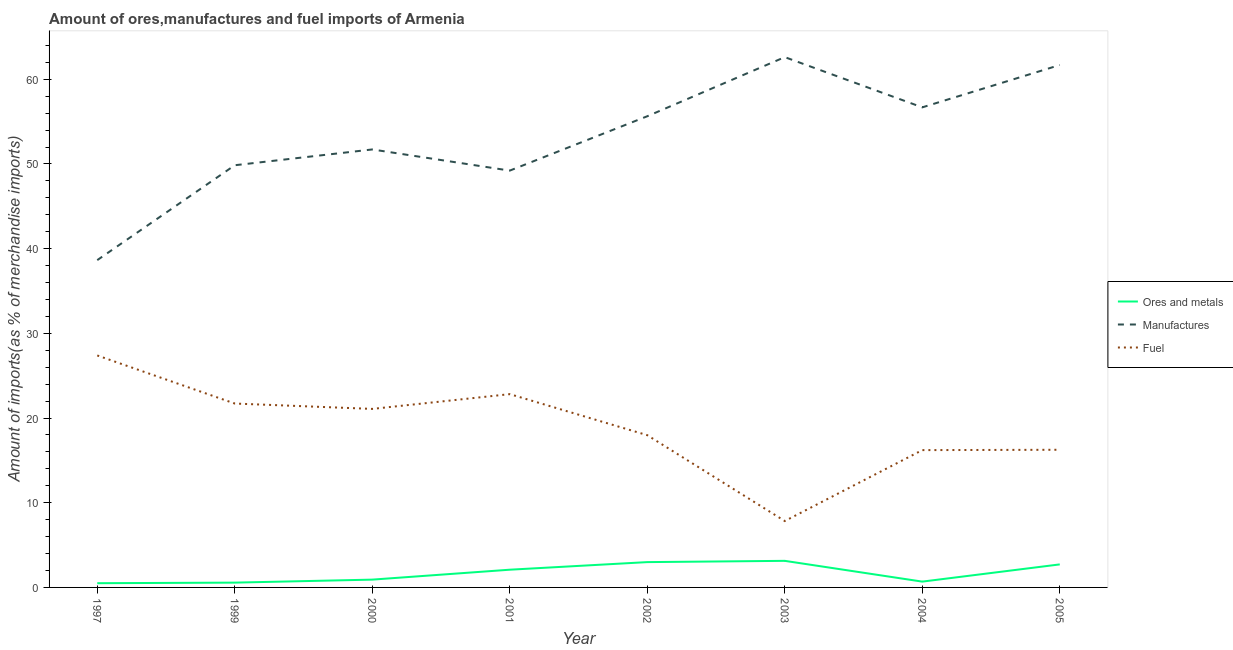How many different coloured lines are there?
Keep it short and to the point. 3. Does the line corresponding to percentage of ores and metals imports intersect with the line corresponding to percentage of manufactures imports?
Make the answer very short. No. What is the percentage of fuel imports in 2001?
Give a very brief answer. 22.82. Across all years, what is the maximum percentage of fuel imports?
Your answer should be very brief. 27.39. Across all years, what is the minimum percentage of manufactures imports?
Ensure brevity in your answer.  38.64. What is the total percentage of ores and metals imports in the graph?
Provide a short and direct response. 13.61. What is the difference between the percentage of ores and metals imports in 2004 and that in 2005?
Offer a terse response. -2.03. What is the difference between the percentage of manufactures imports in 1999 and the percentage of fuel imports in 2005?
Offer a terse response. 33.59. What is the average percentage of fuel imports per year?
Your response must be concise. 18.91. In the year 1999, what is the difference between the percentage of ores and metals imports and percentage of manufactures imports?
Your answer should be compact. -49.28. In how many years, is the percentage of fuel imports greater than 42 %?
Ensure brevity in your answer.  0. What is the ratio of the percentage of fuel imports in 2002 to that in 2004?
Your answer should be very brief. 1.11. What is the difference between the highest and the second highest percentage of fuel imports?
Provide a succinct answer. 4.57. What is the difference between the highest and the lowest percentage of manufactures imports?
Provide a short and direct response. 23.97. In how many years, is the percentage of manufactures imports greater than the average percentage of manufactures imports taken over all years?
Ensure brevity in your answer.  4. Is the sum of the percentage of manufactures imports in 2001 and 2005 greater than the maximum percentage of fuel imports across all years?
Your answer should be compact. Yes. Is the percentage of ores and metals imports strictly greater than the percentage of manufactures imports over the years?
Offer a very short reply. No. What is the difference between two consecutive major ticks on the Y-axis?
Provide a short and direct response. 10. What is the title of the graph?
Your answer should be very brief. Amount of ores,manufactures and fuel imports of Armenia. Does "Transport equipments" appear as one of the legend labels in the graph?
Your answer should be compact. No. What is the label or title of the X-axis?
Your answer should be very brief. Year. What is the label or title of the Y-axis?
Your response must be concise. Amount of imports(as % of merchandise imports). What is the Amount of imports(as % of merchandise imports) of Ores and metals in 1997?
Offer a terse response. 0.5. What is the Amount of imports(as % of merchandise imports) in Manufactures in 1997?
Offer a very short reply. 38.64. What is the Amount of imports(as % of merchandise imports) in Fuel in 1997?
Your answer should be compact. 27.39. What is the Amount of imports(as % of merchandise imports) of Ores and metals in 1999?
Make the answer very short. 0.57. What is the Amount of imports(as % of merchandise imports) of Manufactures in 1999?
Offer a terse response. 49.85. What is the Amount of imports(as % of merchandise imports) in Fuel in 1999?
Your answer should be compact. 21.71. What is the Amount of imports(as % of merchandise imports) in Ores and metals in 2000?
Ensure brevity in your answer.  0.92. What is the Amount of imports(as % of merchandise imports) in Manufactures in 2000?
Provide a short and direct response. 51.71. What is the Amount of imports(as % of merchandise imports) in Fuel in 2000?
Keep it short and to the point. 21.08. What is the Amount of imports(as % of merchandise imports) in Ores and metals in 2001?
Keep it short and to the point. 2.09. What is the Amount of imports(as % of merchandise imports) in Manufactures in 2001?
Give a very brief answer. 49.21. What is the Amount of imports(as % of merchandise imports) in Fuel in 2001?
Make the answer very short. 22.82. What is the Amount of imports(as % of merchandise imports) in Ores and metals in 2002?
Your answer should be very brief. 2.99. What is the Amount of imports(as % of merchandise imports) of Manufactures in 2002?
Provide a succinct answer. 55.63. What is the Amount of imports(as % of merchandise imports) in Fuel in 2002?
Give a very brief answer. 17.98. What is the Amount of imports(as % of merchandise imports) in Ores and metals in 2003?
Provide a succinct answer. 3.14. What is the Amount of imports(as % of merchandise imports) in Manufactures in 2003?
Your response must be concise. 62.61. What is the Amount of imports(as % of merchandise imports) of Fuel in 2003?
Ensure brevity in your answer.  7.84. What is the Amount of imports(as % of merchandise imports) of Ores and metals in 2004?
Offer a terse response. 0.69. What is the Amount of imports(as % of merchandise imports) in Manufactures in 2004?
Your answer should be compact. 56.68. What is the Amount of imports(as % of merchandise imports) of Fuel in 2004?
Make the answer very short. 16.21. What is the Amount of imports(as % of merchandise imports) of Ores and metals in 2005?
Provide a succinct answer. 2.72. What is the Amount of imports(as % of merchandise imports) in Manufactures in 2005?
Make the answer very short. 61.68. What is the Amount of imports(as % of merchandise imports) of Fuel in 2005?
Your answer should be very brief. 16.25. Across all years, what is the maximum Amount of imports(as % of merchandise imports) in Ores and metals?
Make the answer very short. 3.14. Across all years, what is the maximum Amount of imports(as % of merchandise imports) in Manufactures?
Provide a short and direct response. 62.61. Across all years, what is the maximum Amount of imports(as % of merchandise imports) of Fuel?
Offer a very short reply. 27.39. Across all years, what is the minimum Amount of imports(as % of merchandise imports) in Ores and metals?
Provide a succinct answer. 0.5. Across all years, what is the minimum Amount of imports(as % of merchandise imports) in Manufactures?
Provide a succinct answer. 38.64. Across all years, what is the minimum Amount of imports(as % of merchandise imports) of Fuel?
Your answer should be very brief. 7.84. What is the total Amount of imports(as % of merchandise imports) in Ores and metals in the graph?
Offer a terse response. 13.61. What is the total Amount of imports(as % of merchandise imports) of Manufactures in the graph?
Provide a succinct answer. 426.03. What is the total Amount of imports(as % of merchandise imports) in Fuel in the graph?
Your answer should be compact. 151.28. What is the difference between the Amount of imports(as % of merchandise imports) of Ores and metals in 1997 and that in 1999?
Provide a short and direct response. -0.07. What is the difference between the Amount of imports(as % of merchandise imports) in Manufactures in 1997 and that in 1999?
Provide a succinct answer. -11.2. What is the difference between the Amount of imports(as % of merchandise imports) in Fuel in 1997 and that in 1999?
Give a very brief answer. 5.68. What is the difference between the Amount of imports(as % of merchandise imports) in Ores and metals in 1997 and that in 2000?
Provide a short and direct response. -0.42. What is the difference between the Amount of imports(as % of merchandise imports) of Manufactures in 1997 and that in 2000?
Make the answer very short. -13.07. What is the difference between the Amount of imports(as % of merchandise imports) of Fuel in 1997 and that in 2000?
Provide a short and direct response. 6.31. What is the difference between the Amount of imports(as % of merchandise imports) in Ores and metals in 1997 and that in 2001?
Offer a terse response. -1.59. What is the difference between the Amount of imports(as % of merchandise imports) of Manufactures in 1997 and that in 2001?
Ensure brevity in your answer.  -10.57. What is the difference between the Amount of imports(as % of merchandise imports) in Fuel in 1997 and that in 2001?
Ensure brevity in your answer.  4.57. What is the difference between the Amount of imports(as % of merchandise imports) of Ores and metals in 1997 and that in 2002?
Make the answer very short. -2.49. What is the difference between the Amount of imports(as % of merchandise imports) in Manufactures in 1997 and that in 2002?
Your response must be concise. -16.99. What is the difference between the Amount of imports(as % of merchandise imports) of Fuel in 1997 and that in 2002?
Offer a terse response. 9.41. What is the difference between the Amount of imports(as % of merchandise imports) of Ores and metals in 1997 and that in 2003?
Your answer should be compact. -2.64. What is the difference between the Amount of imports(as % of merchandise imports) in Manufactures in 1997 and that in 2003?
Offer a very short reply. -23.97. What is the difference between the Amount of imports(as % of merchandise imports) in Fuel in 1997 and that in 2003?
Offer a terse response. 19.55. What is the difference between the Amount of imports(as % of merchandise imports) of Ores and metals in 1997 and that in 2004?
Make the answer very short. -0.19. What is the difference between the Amount of imports(as % of merchandise imports) in Manufactures in 1997 and that in 2004?
Keep it short and to the point. -18.04. What is the difference between the Amount of imports(as % of merchandise imports) in Fuel in 1997 and that in 2004?
Give a very brief answer. 11.18. What is the difference between the Amount of imports(as % of merchandise imports) in Ores and metals in 1997 and that in 2005?
Give a very brief answer. -2.22. What is the difference between the Amount of imports(as % of merchandise imports) in Manufactures in 1997 and that in 2005?
Give a very brief answer. -23.04. What is the difference between the Amount of imports(as % of merchandise imports) of Fuel in 1997 and that in 2005?
Offer a very short reply. 11.14. What is the difference between the Amount of imports(as % of merchandise imports) in Ores and metals in 1999 and that in 2000?
Ensure brevity in your answer.  -0.35. What is the difference between the Amount of imports(as % of merchandise imports) of Manufactures in 1999 and that in 2000?
Offer a very short reply. -1.86. What is the difference between the Amount of imports(as % of merchandise imports) of Fuel in 1999 and that in 2000?
Make the answer very short. 0.63. What is the difference between the Amount of imports(as % of merchandise imports) of Ores and metals in 1999 and that in 2001?
Make the answer very short. -1.53. What is the difference between the Amount of imports(as % of merchandise imports) of Manufactures in 1999 and that in 2001?
Your answer should be very brief. 0.63. What is the difference between the Amount of imports(as % of merchandise imports) of Fuel in 1999 and that in 2001?
Ensure brevity in your answer.  -1.11. What is the difference between the Amount of imports(as % of merchandise imports) of Ores and metals in 1999 and that in 2002?
Your response must be concise. -2.42. What is the difference between the Amount of imports(as % of merchandise imports) in Manufactures in 1999 and that in 2002?
Give a very brief answer. -5.78. What is the difference between the Amount of imports(as % of merchandise imports) of Fuel in 1999 and that in 2002?
Offer a terse response. 3.74. What is the difference between the Amount of imports(as % of merchandise imports) of Ores and metals in 1999 and that in 2003?
Give a very brief answer. -2.57. What is the difference between the Amount of imports(as % of merchandise imports) in Manufactures in 1999 and that in 2003?
Give a very brief answer. -12.77. What is the difference between the Amount of imports(as % of merchandise imports) in Fuel in 1999 and that in 2003?
Ensure brevity in your answer.  13.87. What is the difference between the Amount of imports(as % of merchandise imports) of Ores and metals in 1999 and that in 2004?
Your answer should be very brief. -0.12. What is the difference between the Amount of imports(as % of merchandise imports) of Manufactures in 1999 and that in 2004?
Offer a very short reply. -6.83. What is the difference between the Amount of imports(as % of merchandise imports) of Fuel in 1999 and that in 2004?
Make the answer very short. 5.5. What is the difference between the Amount of imports(as % of merchandise imports) in Ores and metals in 1999 and that in 2005?
Ensure brevity in your answer.  -2.15. What is the difference between the Amount of imports(as % of merchandise imports) in Manufactures in 1999 and that in 2005?
Your answer should be very brief. -11.83. What is the difference between the Amount of imports(as % of merchandise imports) of Fuel in 1999 and that in 2005?
Your answer should be very brief. 5.46. What is the difference between the Amount of imports(as % of merchandise imports) in Ores and metals in 2000 and that in 2001?
Offer a very short reply. -1.17. What is the difference between the Amount of imports(as % of merchandise imports) in Manufactures in 2000 and that in 2001?
Offer a terse response. 2.5. What is the difference between the Amount of imports(as % of merchandise imports) in Fuel in 2000 and that in 2001?
Keep it short and to the point. -1.74. What is the difference between the Amount of imports(as % of merchandise imports) of Ores and metals in 2000 and that in 2002?
Your answer should be very brief. -2.07. What is the difference between the Amount of imports(as % of merchandise imports) of Manufactures in 2000 and that in 2002?
Provide a short and direct response. -3.92. What is the difference between the Amount of imports(as % of merchandise imports) of Fuel in 2000 and that in 2002?
Offer a very short reply. 3.1. What is the difference between the Amount of imports(as % of merchandise imports) in Ores and metals in 2000 and that in 2003?
Your answer should be very brief. -2.22. What is the difference between the Amount of imports(as % of merchandise imports) of Manufactures in 2000 and that in 2003?
Your response must be concise. -10.9. What is the difference between the Amount of imports(as % of merchandise imports) in Fuel in 2000 and that in 2003?
Your answer should be very brief. 13.24. What is the difference between the Amount of imports(as % of merchandise imports) in Ores and metals in 2000 and that in 2004?
Ensure brevity in your answer.  0.24. What is the difference between the Amount of imports(as % of merchandise imports) of Manufactures in 2000 and that in 2004?
Give a very brief answer. -4.97. What is the difference between the Amount of imports(as % of merchandise imports) in Fuel in 2000 and that in 2004?
Provide a short and direct response. 4.87. What is the difference between the Amount of imports(as % of merchandise imports) of Ores and metals in 2000 and that in 2005?
Provide a succinct answer. -1.8. What is the difference between the Amount of imports(as % of merchandise imports) of Manufactures in 2000 and that in 2005?
Provide a short and direct response. -9.97. What is the difference between the Amount of imports(as % of merchandise imports) in Fuel in 2000 and that in 2005?
Offer a terse response. 4.82. What is the difference between the Amount of imports(as % of merchandise imports) of Ores and metals in 2001 and that in 2002?
Offer a terse response. -0.9. What is the difference between the Amount of imports(as % of merchandise imports) in Manufactures in 2001 and that in 2002?
Your answer should be very brief. -6.42. What is the difference between the Amount of imports(as % of merchandise imports) of Fuel in 2001 and that in 2002?
Offer a very short reply. 4.85. What is the difference between the Amount of imports(as % of merchandise imports) in Ores and metals in 2001 and that in 2003?
Provide a short and direct response. -1.05. What is the difference between the Amount of imports(as % of merchandise imports) of Manufactures in 2001 and that in 2003?
Provide a succinct answer. -13.4. What is the difference between the Amount of imports(as % of merchandise imports) in Fuel in 2001 and that in 2003?
Offer a very short reply. 14.98. What is the difference between the Amount of imports(as % of merchandise imports) of Ores and metals in 2001 and that in 2004?
Your answer should be very brief. 1.41. What is the difference between the Amount of imports(as % of merchandise imports) in Manufactures in 2001 and that in 2004?
Provide a short and direct response. -7.47. What is the difference between the Amount of imports(as % of merchandise imports) of Fuel in 2001 and that in 2004?
Your answer should be compact. 6.61. What is the difference between the Amount of imports(as % of merchandise imports) of Ores and metals in 2001 and that in 2005?
Your answer should be very brief. -0.63. What is the difference between the Amount of imports(as % of merchandise imports) of Manufactures in 2001 and that in 2005?
Give a very brief answer. -12.47. What is the difference between the Amount of imports(as % of merchandise imports) of Fuel in 2001 and that in 2005?
Offer a terse response. 6.57. What is the difference between the Amount of imports(as % of merchandise imports) of Ores and metals in 2002 and that in 2003?
Offer a very short reply. -0.15. What is the difference between the Amount of imports(as % of merchandise imports) of Manufactures in 2002 and that in 2003?
Offer a terse response. -6.98. What is the difference between the Amount of imports(as % of merchandise imports) of Fuel in 2002 and that in 2003?
Your answer should be compact. 10.14. What is the difference between the Amount of imports(as % of merchandise imports) of Ores and metals in 2002 and that in 2004?
Your response must be concise. 2.3. What is the difference between the Amount of imports(as % of merchandise imports) in Manufactures in 2002 and that in 2004?
Offer a very short reply. -1.05. What is the difference between the Amount of imports(as % of merchandise imports) in Fuel in 2002 and that in 2004?
Ensure brevity in your answer.  1.76. What is the difference between the Amount of imports(as % of merchandise imports) of Ores and metals in 2002 and that in 2005?
Provide a short and direct response. 0.27. What is the difference between the Amount of imports(as % of merchandise imports) in Manufactures in 2002 and that in 2005?
Keep it short and to the point. -6.05. What is the difference between the Amount of imports(as % of merchandise imports) in Fuel in 2002 and that in 2005?
Your response must be concise. 1.72. What is the difference between the Amount of imports(as % of merchandise imports) of Ores and metals in 2003 and that in 2004?
Your answer should be compact. 2.45. What is the difference between the Amount of imports(as % of merchandise imports) in Manufactures in 2003 and that in 2004?
Your response must be concise. 5.93. What is the difference between the Amount of imports(as % of merchandise imports) of Fuel in 2003 and that in 2004?
Make the answer very short. -8.37. What is the difference between the Amount of imports(as % of merchandise imports) of Ores and metals in 2003 and that in 2005?
Your answer should be very brief. 0.42. What is the difference between the Amount of imports(as % of merchandise imports) of Manufactures in 2003 and that in 2005?
Offer a very short reply. 0.93. What is the difference between the Amount of imports(as % of merchandise imports) in Fuel in 2003 and that in 2005?
Offer a very short reply. -8.41. What is the difference between the Amount of imports(as % of merchandise imports) of Ores and metals in 2004 and that in 2005?
Make the answer very short. -2.03. What is the difference between the Amount of imports(as % of merchandise imports) in Manufactures in 2004 and that in 2005?
Give a very brief answer. -5. What is the difference between the Amount of imports(as % of merchandise imports) of Fuel in 2004 and that in 2005?
Give a very brief answer. -0.04. What is the difference between the Amount of imports(as % of merchandise imports) in Ores and metals in 1997 and the Amount of imports(as % of merchandise imports) in Manufactures in 1999?
Offer a terse response. -49.35. What is the difference between the Amount of imports(as % of merchandise imports) in Ores and metals in 1997 and the Amount of imports(as % of merchandise imports) in Fuel in 1999?
Provide a short and direct response. -21.21. What is the difference between the Amount of imports(as % of merchandise imports) of Manufactures in 1997 and the Amount of imports(as % of merchandise imports) of Fuel in 1999?
Your answer should be very brief. 16.93. What is the difference between the Amount of imports(as % of merchandise imports) of Ores and metals in 1997 and the Amount of imports(as % of merchandise imports) of Manufactures in 2000?
Ensure brevity in your answer.  -51.21. What is the difference between the Amount of imports(as % of merchandise imports) in Ores and metals in 1997 and the Amount of imports(as % of merchandise imports) in Fuel in 2000?
Your answer should be compact. -20.58. What is the difference between the Amount of imports(as % of merchandise imports) of Manufactures in 1997 and the Amount of imports(as % of merchandise imports) of Fuel in 2000?
Your response must be concise. 17.57. What is the difference between the Amount of imports(as % of merchandise imports) in Ores and metals in 1997 and the Amount of imports(as % of merchandise imports) in Manufactures in 2001?
Your answer should be very brief. -48.72. What is the difference between the Amount of imports(as % of merchandise imports) in Ores and metals in 1997 and the Amount of imports(as % of merchandise imports) in Fuel in 2001?
Your response must be concise. -22.32. What is the difference between the Amount of imports(as % of merchandise imports) of Manufactures in 1997 and the Amount of imports(as % of merchandise imports) of Fuel in 2001?
Ensure brevity in your answer.  15.82. What is the difference between the Amount of imports(as % of merchandise imports) of Ores and metals in 1997 and the Amount of imports(as % of merchandise imports) of Manufactures in 2002?
Make the answer very short. -55.13. What is the difference between the Amount of imports(as % of merchandise imports) in Ores and metals in 1997 and the Amount of imports(as % of merchandise imports) in Fuel in 2002?
Offer a very short reply. -17.48. What is the difference between the Amount of imports(as % of merchandise imports) in Manufactures in 1997 and the Amount of imports(as % of merchandise imports) in Fuel in 2002?
Provide a succinct answer. 20.67. What is the difference between the Amount of imports(as % of merchandise imports) in Ores and metals in 1997 and the Amount of imports(as % of merchandise imports) in Manufactures in 2003?
Ensure brevity in your answer.  -62.12. What is the difference between the Amount of imports(as % of merchandise imports) in Ores and metals in 1997 and the Amount of imports(as % of merchandise imports) in Fuel in 2003?
Ensure brevity in your answer.  -7.34. What is the difference between the Amount of imports(as % of merchandise imports) of Manufactures in 1997 and the Amount of imports(as % of merchandise imports) of Fuel in 2003?
Your answer should be compact. 30.81. What is the difference between the Amount of imports(as % of merchandise imports) in Ores and metals in 1997 and the Amount of imports(as % of merchandise imports) in Manufactures in 2004?
Your response must be concise. -56.18. What is the difference between the Amount of imports(as % of merchandise imports) in Ores and metals in 1997 and the Amount of imports(as % of merchandise imports) in Fuel in 2004?
Your answer should be compact. -15.71. What is the difference between the Amount of imports(as % of merchandise imports) in Manufactures in 1997 and the Amount of imports(as % of merchandise imports) in Fuel in 2004?
Provide a succinct answer. 22.43. What is the difference between the Amount of imports(as % of merchandise imports) of Ores and metals in 1997 and the Amount of imports(as % of merchandise imports) of Manufactures in 2005?
Your answer should be compact. -61.18. What is the difference between the Amount of imports(as % of merchandise imports) in Ores and metals in 1997 and the Amount of imports(as % of merchandise imports) in Fuel in 2005?
Give a very brief answer. -15.76. What is the difference between the Amount of imports(as % of merchandise imports) in Manufactures in 1997 and the Amount of imports(as % of merchandise imports) in Fuel in 2005?
Provide a succinct answer. 22.39. What is the difference between the Amount of imports(as % of merchandise imports) in Ores and metals in 1999 and the Amount of imports(as % of merchandise imports) in Manufactures in 2000?
Your response must be concise. -51.15. What is the difference between the Amount of imports(as % of merchandise imports) of Ores and metals in 1999 and the Amount of imports(as % of merchandise imports) of Fuel in 2000?
Your answer should be very brief. -20.51. What is the difference between the Amount of imports(as % of merchandise imports) of Manufactures in 1999 and the Amount of imports(as % of merchandise imports) of Fuel in 2000?
Your answer should be very brief. 28.77. What is the difference between the Amount of imports(as % of merchandise imports) in Ores and metals in 1999 and the Amount of imports(as % of merchandise imports) in Manufactures in 2001?
Your answer should be very brief. -48.65. What is the difference between the Amount of imports(as % of merchandise imports) in Ores and metals in 1999 and the Amount of imports(as % of merchandise imports) in Fuel in 2001?
Give a very brief answer. -22.26. What is the difference between the Amount of imports(as % of merchandise imports) in Manufactures in 1999 and the Amount of imports(as % of merchandise imports) in Fuel in 2001?
Your answer should be compact. 27.03. What is the difference between the Amount of imports(as % of merchandise imports) in Ores and metals in 1999 and the Amount of imports(as % of merchandise imports) in Manufactures in 2002?
Provide a succinct answer. -55.07. What is the difference between the Amount of imports(as % of merchandise imports) of Ores and metals in 1999 and the Amount of imports(as % of merchandise imports) of Fuel in 2002?
Offer a terse response. -17.41. What is the difference between the Amount of imports(as % of merchandise imports) of Manufactures in 1999 and the Amount of imports(as % of merchandise imports) of Fuel in 2002?
Make the answer very short. 31.87. What is the difference between the Amount of imports(as % of merchandise imports) in Ores and metals in 1999 and the Amount of imports(as % of merchandise imports) in Manufactures in 2003?
Your answer should be compact. -62.05. What is the difference between the Amount of imports(as % of merchandise imports) in Ores and metals in 1999 and the Amount of imports(as % of merchandise imports) in Fuel in 2003?
Ensure brevity in your answer.  -7.27. What is the difference between the Amount of imports(as % of merchandise imports) in Manufactures in 1999 and the Amount of imports(as % of merchandise imports) in Fuel in 2003?
Make the answer very short. 42.01. What is the difference between the Amount of imports(as % of merchandise imports) of Ores and metals in 1999 and the Amount of imports(as % of merchandise imports) of Manufactures in 2004?
Your answer should be compact. -56.12. What is the difference between the Amount of imports(as % of merchandise imports) of Ores and metals in 1999 and the Amount of imports(as % of merchandise imports) of Fuel in 2004?
Keep it short and to the point. -15.65. What is the difference between the Amount of imports(as % of merchandise imports) in Manufactures in 1999 and the Amount of imports(as % of merchandise imports) in Fuel in 2004?
Make the answer very short. 33.64. What is the difference between the Amount of imports(as % of merchandise imports) of Ores and metals in 1999 and the Amount of imports(as % of merchandise imports) of Manufactures in 2005?
Provide a succinct answer. -61.12. What is the difference between the Amount of imports(as % of merchandise imports) in Ores and metals in 1999 and the Amount of imports(as % of merchandise imports) in Fuel in 2005?
Provide a succinct answer. -15.69. What is the difference between the Amount of imports(as % of merchandise imports) of Manufactures in 1999 and the Amount of imports(as % of merchandise imports) of Fuel in 2005?
Your answer should be very brief. 33.59. What is the difference between the Amount of imports(as % of merchandise imports) in Ores and metals in 2000 and the Amount of imports(as % of merchandise imports) in Manufactures in 2001?
Make the answer very short. -48.29. What is the difference between the Amount of imports(as % of merchandise imports) in Ores and metals in 2000 and the Amount of imports(as % of merchandise imports) in Fuel in 2001?
Ensure brevity in your answer.  -21.9. What is the difference between the Amount of imports(as % of merchandise imports) in Manufactures in 2000 and the Amount of imports(as % of merchandise imports) in Fuel in 2001?
Make the answer very short. 28.89. What is the difference between the Amount of imports(as % of merchandise imports) in Ores and metals in 2000 and the Amount of imports(as % of merchandise imports) in Manufactures in 2002?
Offer a terse response. -54.71. What is the difference between the Amount of imports(as % of merchandise imports) in Ores and metals in 2000 and the Amount of imports(as % of merchandise imports) in Fuel in 2002?
Your answer should be compact. -17.05. What is the difference between the Amount of imports(as % of merchandise imports) of Manufactures in 2000 and the Amount of imports(as % of merchandise imports) of Fuel in 2002?
Ensure brevity in your answer.  33.74. What is the difference between the Amount of imports(as % of merchandise imports) in Ores and metals in 2000 and the Amount of imports(as % of merchandise imports) in Manufactures in 2003?
Keep it short and to the point. -61.69. What is the difference between the Amount of imports(as % of merchandise imports) of Ores and metals in 2000 and the Amount of imports(as % of merchandise imports) of Fuel in 2003?
Your answer should be compact. -6.92. What is the difference between the Amount of imports(as % of merchandise imports) in Manufactures in 2000 and the Amount of imports(as % of merchandise imports) in Fuel in 2003?
Make the answer very short. 43.87. What is the difference between the Amount of imports(as % of merchandise imports) in Ores and metals in 2000 and the Amount of imports(as % of merchandise imports) in Manufactures in 2004?
Keep it short and to the point. -55.76. What is the difference between the Amount of imports(as % of merchandise imports) in Ores and metals in 2000 and the Amount of imports(as % of merchandise imports) in Fuel in 2004?
Give a very brief answer. -15.29. What is the difference between the Amount of imports(as % of merchandise imports) of Manufactures in 2000 and the Amount of imports(as % of merchandise imports) of Fuel in 2004?
Keep it short and to the point. 35.5. What is the difference between the Amount of imports(as % of merchandise imports) of Ores and metals in 2000 and the Amount of imports(as % of merchandise imports) of Manufactures in 2005?
Your response must be concise. -60.76. What is the difference between the Amount of imports(as % of merchandise imports) in Ores and metals in 2000 and the Amount of imports(as % of merchandise imports) in Fuel in 2005?
Make the answer very short. -15.33. What is the difference between the Amount of imports(as % of merchandise imports) of Manufactures in 2000 and the Amount of imports(as % of merchandise imports) of Fuel in 2005?
Make the answer very short. 35.46. What is the difference between the Amount of imports(as % of merchandise imports) in Ores and metals in 2001 and the Amount of imports(as % of merchandise imports) in Manufactures in 2002?
Ensure brevity in your answer.  -53.54. What is the difference between the Amount of imports(as % of merchandise imports) of Ores and metals in 2001 and the Amount of imports(as % of merchandise imports) of Fuel in 2002?
Ensure brevity in your answer.  -15.88. What is the difference between the Amount of imports(as % of merchandise imports) of Manufactures in 2001 and the Amount of imports(as % of merchandise imports) of Fuel in 2002?
Ensure brevity in your answer.  31.24. What is the difference between the Amount of imports(as % of merchandise imports) of Ores and metals in 2001 and the Amount of imports(as % of merchandise imports) of Manufactures in 2003?
Provide a short and direct response. -60.52. What is the difference between the Amount of imports(as % of merchandise imports) in Ores and metals in 2001 and the Amount of imports(as % of merchandise imports) in Fuel in 2003?
Make the answer very short. -5.75. What is the difference between the Amount of imports(as % of merchandise imports) in Manufactures in 2001 and the Amount of imports(as % of merchandise imports) in Fuel in 2003?
Keep it short and to the point. 41.38. What is the difference between the Amount of imports(as % of merchandise imports) in Ores and metals in 2001 and the Amount of imports(as % of merchandise imports) in Manufactures in 2004?
Ensure brevity in your answer.  -54.59. What is the difference between the Amount of imports(as % of merchandise imports) in Ores and metals in 2001 and the Amount of imports(as % of merchandise imports) in Fuel in 2004?
Offer a very short reply. -14.12. What is the difference between the Amount of imports(as % of merchandise imports) in Manufactures in 2001 and the Amount of imports(as % of merchandise imports) in Fuel in 2004?
Give a very brief answer. 33. What is the difference between the Amount of imports(as % of merchandise imports) in Ores and metals in 2001 and the Amount of imports(as % of merchandise imports) in Manufactures in 2005?
Keep it short and to the point. -59.59. What is the difference between the Amount of imports(as % of merchandise imports) in Ores and metals in 2001 and the Amount of imports(as % of merchandise imports) in Fuel in 2005?
Offer a very short reply. -14.16. What is the difference between the Amount of imports(as % of merchandise imports) of Manufactures in 2001 and the Amount of imports(as % of merchandise imports) of Fuel in 2005?
Offer a terse response. 32.96. What is the difference between the Amount of imports(as % of merchandise imports) of Ores and metals in 2002 and the Amount of imports(as % of merchandise imports) of Manufactures in 2003?
Make the answer very short. -59.62. What is the difference between the Amount of imports(as % of merchandise imports) of Ores and metals in 2002 and the Amount of imports(as % of merchandise imports) of Fuel in 2003?
Your response must be concise. -4.85. What is the difference between the Amount of imports(as % of merchandise imports) of Manufactures in 2002 and the Amount of imports(as % of merchandise imports) of Fuel in 2003?
Make the answer very short. 47.79. What is the difference between the Amount of imports(as % of merchandise imports) of Ores and metals in 2002 and the Amount of imports(as % of merchandise imports) of Manufactures in 2004?
Offer a terse response. -53.69. What is the difference between the Amount of imports(as % of merchandise imports) of Ores and metals in 2002 and the Amount of imports(as % of merchandise imports) of Fuel in 2004?
Your answer should be very brief. -13.22. What is the difference between the Amount of imports(as % of merchandise imports) of Manufactures in 2002 and the Amount of imports(as % of merchandise imports) of Fuel in 2004?
Offer a terse response. 39.42. What is the difference between the Amount of imports(as % of merchandise imports) in Ores and metals in 2002 and the Amount of imports(as % of merchandise imports) in Manufactures in 2005?
Ensure brevity in your answer.  -58.69. What is the difference between the Amount of imports(as % of merchandise imports) in Ores and metals in 2002 and the Amount of imports(as % of merchandise imports) in Fuel in 2005?
Provide a short and direct response. -13.26. What is the difference between the Amount of imports(as % of merchandise imports) in Manufactures in 2002 and the Amount of imports(as % of merchandise imports) in Fuel in 2005?
Keep it short and to the point. 39.38. What is the difference between the Amount of imports(as % of merchandise imports) of Ores and metals in 2003 and the Amount of imports(as % of merchandise imports) of Manufactures in 2004?
Your answer should be compact. -53.54. What is the difference between the Amount of imports(as % of merchandise imports) of Ores and metals in 2003 and the Amount of imports(as % of merchandise imports) of Fuel in 2004?
Your response must be concise. -13.07. What is the difference between the Amount of imports(as % of merchandise imports) in Manufactures in 2003 and the Amount of imports(as % of merchandise imports) in Fuel in 2004?
Keep it short and to the point. 46.4. What is the difference between the Amount of imports(as % of merchandise imports) of Ores and metals in 2003 and the Amount of imports(as % of merchandise imports) of Manufactures in 2005?
Keep it short and to the point. -58.54. What is the difference between the Amount of imports(as % of merchandise imports) of Ores and metals in 2003 and the Amount of imports(as % of merchandise imports) of Fuel in 2005?
Offer a very short reply. -13.12. What is the difference between the Amount of imports(as % of merchandise imports) in Manufactures in 2003 and the Amount of imports(as % of merchandise imports) in Fuel in 2005?
Provide a succinct answer. 46.36. What is the difference between the Amount of imports(as % of merchandise imports) in Ores and metals in 2004 and the Amount of imports(as % of merchandise imports) in Manufactures in 2005?
Keep it short and to the point. -61. What is the difference between the Amount of imports(as % of merchandise imports) of Ores and metals in 2004 and the Amount of imports(as % of merchandise imports) of Fuel in 2005?
Your response must be concise. -15.57. What is the difference between the Amount of imports(as % of merchandise imports) in Manufactures in 2004 and the Amount of imports(as % of merchandise imports) in Fuel in 2005?
Your answer should be very brief. 40.43. What is the average Amount of imports(as % of merchandise imports) of Ores and metals per year?
Your answer should be very brief. 1.7. What is the average Amount of imports(as % of merchandise imports) of Manufactures per year?
Your answer should be very brief. 53.25. What is the average Amount of imports(as % of merchandise imports) of Fuel per year?
Your response must be concise. 18.91. In the year 1997, what is the difference between the Amount of imports(as % of merchandise imports) of Ores and metals and Amount of imports(as % of merchandise imports) of Manufactures?
Ensure brevity in your answer.  -38.15. In the year 1997, what is the difference between the Amount of imports(as % of merchandise imports) of Ores and metals and Amount of imports(as % of merchandise imports) of Fuel?
Your response must be concise. -26.89. In the year 1997, what is the difference between the Amount of imports(as % of merchandise imports) of Manufactures and Amount of imports(as % of merchandise imports) of Fuel?
Offer a terse response. 11.26. In the year 1999, what is the difference between the Amount of imports(as % of merchandise imports) in Ores and metals and Amount of imports(as % of merchandise imports) in Manufactures?
Provide a succinct answer. -49.28. In the year 1999, what is the difference between the Amount of imports(as % of merchandise imports) in Ores and metals and Amount of imports(as % of merchandise imports) in Fuel?
Your answer should be compact. -21.15. In the year 1999, what is the difference between the Amount of imports(as % of merchandise imports) in Manufactures and Amount of imports(as % of merchandise imports) in Fuel?
Provide a succinct answer. 28.14. In the year 2000, what is the difference between the Amount of imports(as % of merchandise imports) of Ores and metals and Amount of imports(as % of merchandise imports) of Manufactures?
Make the answer very short. -50.79. In the year 2000, what is the difference between the Amount of imports(as % of merchandise imports) in Ores and metals and Amount of imports(as % of merchandise imports) in Fuel?
Provide a short and direct response. -20.16. In the year 2000, what is the difference between the Amount of imports(as % of merchandise imports) of Manufactures and Amount of imports(as % of merchandise imports) of Fuel?
Keep it short and to the point. 30.63. In the year 2001, what is the difference between the Amount of imports(as % of merchandise imports) in Ores and metals and Amount of imports(as % of merchandise imports) in Manufactures?
Offer a terse response. -47.12. In the year 2001, what is the difference between the Amount of imports(as % of merchandise imports) in Ores and metals and Amount of imports(as % of merchandise imports) in Fuel?
Your response must be concise. -20.73. In the year 2001, what is the difference between the Amount of imports(as % of merchandise imports) in Manufactures and Amount of imports(as % of merchandise imports) in Fuel?
Offer a very short reply. 26.39. In the year 2002, what is the difference between the Amount of imports(as % of merchandise imports) in Ores and metals and Amount of imports(as % of merchandise imports) in Manufactures?
Offer a terse response. -52.64. In the year 2002, what is the difference between the Amount of imports(as % of merchandise imports) of Ores and metals and Amount of imports(as % of merchandise imports) of Fuel?
Your answer should be compact. -14.99. In the year 2002, what is the difference between the Amount of imports(as % of merchandise imports) of Manufactures and Amount of imports(as % of merchandise imports) of Fuel?
Your response must be concise. 37.66. In the year 2003, what is the difference between the Amount of imports(as % of merchandise imports) in Ores and metals and Amount of imports(as % of merchandise imports) in Manufactures?
Offer a very short reply. -59.48. In the year 2003, what is the difference between the Amount of imports(as % of merchandise imports) of Ores and metals and Amount of imports(as % of merchandise imports) of Fuel?
Provide a succinct answer. -4.7. In the year 2003, what is the difference between the Amount of imports(as % of merchandise imports) of Manufactures and Amount of imports(as % of merchandise imports) of Fuel?
Ensure brevity in your answer.  54.77. In the year 2004, what is the difference between the Amount of imports(as % of merchandise imports) in Ores and metals and Amount of imports(as % of merchandise imports) in Manufactures?
Keep it short and to the point. -56. In the year 2004, what is the difference between the Amount of imports(as % of merchandise imports) in Ores and metals and Amount of imports(as % of merchandise imports) in Fuel?
Offer a very short reply. -15.53. In the year 2004, what is the difference between the Amount of imports(as % of merchandise imports) in Manufactures and Amount of imports(as % of merchandise imports) in Fuel?
Your answer should be compact. 40.47. In the year 2005, what is the difference between the Amount of imports(as % of merchandise imports) of Ores and metals and Amount of imports(as % of merchandise imports) of Manufactures?
Provide a short and direct response. -58.96. In the year 2005, what is the difference between the Amount of imports(as % of merchandise imports) of Ores and metals and Amount of imports(as % of merchandise imports) of Fuel?
Your response must be concise. -13.53. In the year 2005, what is the difference between the Amount of imports(as % of merchandise imports) of Manufactures and Amount of imports(as % of merchandise imports) of Fuel?
Make the answer very short. 45.43. What is the ratio of the Amount of imports(as % of merchandise imports) of Ores and metals in 1997 to that in 1999?
Provide a short and direct response. 0.88. What is the ratio of the Amount of imports(as % of merchandise imports) of Manufactures in 1997 to that in 1999?
Give a very brief answer. 0.78. What is the ratio of the Amount of imports(as % of merchandise imports) of Fuel in 1997 to that in 1999?
Offer a terse response. 1.26. What is the ratio of the Amount of imports(as % of merchandise imports) in Ores and metals in 1997 to that in 2000?
Your answer should be compact. 0.54. What is the ratio of the Amount of imports(as % of merchandise imports) in Manufactures in 1997 to that in 2000?
Make the answer very short. 0.75. What is the ratio of the Amount of imports(as % of merchandise imports) of Fuel in 1997 to that in 2000?
Your answer should be compact. 1.3. What is the ratio of the Amount of imports(as % of merchandise imports) of Ores and metals in 1997 to that in 2001?
Offer a very short reply. 0.24. What is the ratio of the Amount of imports(as % of merchandise imports) of Manufactures in 1997 to that in 2001?
Provide a short and direct response. 0.79. What is the ratio of the Amount of imports(as % of merchandise imports) of Fuel in 1997 to that in 2001?
Your answer should be very brief. 1.2. What is the ratio of the Amount of imports(as % of merchandise imports) in Manufactures in 1997 to that in 2002?
Offer a terse response. 0.69. What is the ratio of the Amount of imports(as % of merchandise imports) of Fuel in 1997 to that in 2002?
Ensure brevity in your answer.  1.52. What is the ratio of the Amount of imports(as % of merchandise imports) in Ores and metals in 1997 to that in 2003?
Keep it short and to the point. 0.16. What is the ratio of the Amount of imports(as % of merchandise imports) in Manufactures in 1997 to that in 2003?
Keep it short and to the point. 0.62. What is the ratio of the Amount of imports(as % of merchandise imports) in Fuel in 1997 to that in 2003?
Ensure brevity in your answer.  3.49. What is the ratio of the Amount of imports(as % of merchandise imports) in Ores and metals in 1997 to that in 2004?
Ensure brevity in your answer.  0.73. What is the ratio of the Amount of imports(as % of merchandise imports) of Manufactures in 1997 to that in 2004?
Provide a succinct answer. 0.68. What is the ratio of the Amount of imports(as % of merchandise imports) in Fuel in 1997 to that in 2004?
Offer a terse response. 1.69. What is the ratio of the Amount of imports(as % of merchandise imports) in Ores and metals in 1997 to that in 2005?
Provide a short and direct response. 0.18. What is the ratio of the Amount of imports(as % of merchandise imports) of Manufactures in 1997 to that in 2005?
Offer a very short reply. 0.63. What is the ratio of the Amount of imports(as % of merchandise imports) in Fuel in 1997 to that in 2005?
Your response must be concise. 1.69. What is the ratio of the Amount of imports(as % of merchandise imports) in Ores and metals in 1999 to that in 2000?
Give a very brief answer. 0.61. What is the ratio of the Amount of imports(as % of merchandise imports) of Manufactures in 1999 to that in 2000?
Offer a terse response. 0.96. What is the ratio of the Amount of imports(as % of merchandise imports) in Fuel in 1999 to that in 2000?
Make the answer very short. 1.03. What is the ratio of the Amount of imports(as % of merchandise imports) of Ores and metals in 1999 to that in 2001?
Keep it short and to the point. 0.27. What is the ratio of the Amount of imports(as % of merchandise imports) in Manufactures in 1999 to that in 2001?
Provide a succinct answer. 1.01. What is the ratio of the Amount of imports(as % of merchandise imports) of Fuel in 1999 to that in 2001?
Offer a very short reply. 0.95. What is the ratio of the Amount of imports(as % of merchandise imports) of Ores and metals in 1999 to that in 2002?
Your response must be concise. 0.19. What is the ratio of the Amount of imports(as % of merchandise imports) in Manufactures in 1999 to that in 2002?
Your answer should be compact. 0.9. What is the ratio of the Amount of imports(as % of merchandise imports) of Fuel in 1999 to that in 2002?
Provide a succinct answer. 1.21. What is the ratio of the Amount of imports(as % of merchandise imports) of Ores and metals in 1999 to that in 2003?
Your answer should be very brief. 0.18. What is the ratio of the Amount of imports(as % of merchandise imports) of Manufactures in 1999 to that in 2003?
Provide a short and direct response. 0.8. What is the ratio of the Amount of imports(as % of merchandise imports) of Fuel in 1999 to that in 2003?
Provide a succinct answer. 2.77. What is the ratio of the Amount of imports(as % of merchandise imports) of Ores and metals in 1999 to that in 2004?
Offer a very short reply. 0.83. What is the ratio of the Amount of imports(as % of merchandise imports) in Manufactures in 1999 to that in 2004?
Your answer should be very brief. 0.88. What is the ratio of the Amount of imports(as % of merchandise imports) in Fuel in 1999 to that in 2004?
Give a very brief answer. 1.34. What is the ratio of the Amount of imports(as % of merchandise imports) of Ores and metals in 1999 to that in 2005?
Keep it short and to the point. 0.21. What is the ratio of the Amount of imports(as % of merchandise imports) in Manufactures in 1999 to that in 2005?
Make the answer very short. 0.81. What is the ratio of the Amount of imports(as % of merchandise imports) of Fuel in 1999 to that in 2005?
Your answer should be very brief. 1.34. What is the ratio of the Amount of imports(as % of merchandise imports) in Ores and metals in 2000 to that in 2001?
Offer a very short reply. 0.44. What is the ratio of the Amount of imports(as % of merchandise imports) in Manufactures in 2000 to that in 2001?
Ensure brevity in your answer.  1.05. What is the ratio of the Amount of imports(as % of merchandise imports) in Fuel in 2000 to that in 2001?
Your answer should be compact. 0.92. What is the ratio of the Amount of imports(as % of merchandise imports) of Ores and metals in 2000 to that in 2002?
Keep it short and to the point. 0.31. What is the ratio of the Amount of imports(as % of merchandise imports) in Manufactures in 2000 to that in 2002?
Provide a succinct answer. 0.93. What is the ratio of the Amount of imports(as % of merchandise imports) in Fuel in 2000 to that in 2002?
Your answer should be compact. 1.17. What is the ratio of the Amount of imports(as % of merchandise imports) in Ores and metals in 2000 to that in 2003?
Make the answer very short. 0.29. What is the ratio of the Amount of imports(as % of merchandise imports) in Manufactures in 2000 to that in 2003?
Keep it short and to the point. 0.83. What is the ratio of the Amount of imports(as % of merchandise imports) of Fuel in 2000 to that in 2003?
Your answer should be compact. 2.69. What is the ratio of the Amount of imports(as % of merchandise imports) of Ores and metals in 2000 to that in 2004?
Make the answer very short. 1.34. What is the ratio of the Amount of imports(as % of merchandise imports) of Manufactures in 2000 to that in 2004?
Make the answer very short. 0.91. What is the ratio of the Amount of imports(as % of merchandise imports) of Fuel in 2000 to that in 2004?
Your response must be concise. 1.3. What is the ratio of the Amount of imports(as % of merchandise imports) in Ores and metals in 2000 to that in 2005?
Keep it short and to the point. 0.34. What is the ratio of the Amount of imports(as % of merchandise imports) of Manufactures in 2000 to that in 2005?
Provide a succinct answer. 0.84. What is the ratio of the Amount of imports(as % of merchandise imports) of Fuel in 2000 to that in 2005?
Give a very brief answer. 1.3. What is the ratio of the Amount of imports(as % of merchandise imports) in Ores and metals in 2001 to that in 2002?
Keep it short and to the point. 0.7. What is the ratio of the Amount of imports(as % of merchandise imports) in Manufactures in 2001 to that in 2002?
Offer a very short reply. 0.88. What is the ratio of the Amount of imports(as % of merchandise imports) in Fuel in 2001 to that in 2002?
Your answer should be very brief. 1.27. What is the ratio of the Amount of imports(as % of merchandise imports) of Ores and metals in 2001 to that in 2003?
Offer a very short reply. 0.67. What is the ratio of the Amount of imports(as % of merchandise imports) in Manufactures in 2001 to that in 2003?
Keep it short and to the point. 0.79. What is the ratio of the Amount of imports(as % of merchandise imports) of Fuel in 2001 to that in 2003?
Give a very brief answer. 2.91. What is the ratio of the Amount of imports(as % of merchandise imports) of Ores and metals in 2001 to that in 2004?
Give a very brief answer. 3.05. What is the ratio of the Amount of imports(as % of merchandise imports) in Manufactures in 2001 to that in 2004?
Your answer should be compact. 0.87. What is the ratio of the Amount of imports(as % of merchandise imports) of Fuel in 2001 to that in 2004?
Make the answer very short. 1.41. What is the ratio of the Amount of imports(as % of merchandise imports) of Ores and metals in 2001 to that in 2005?
Give a very brief answer. 0.77. What is the ratio of the Amount of imports(as % of merchandise imports) in Manufactures in 2001 to that in 2005?
Offer a terse response. 0.8. What is the ratio of the Amount of imports(as % of merchandise imports) of Fuel in 2001 to that in 2005?
Provide a short and direct response. 1.4. What is the ratio of the Amount of imports(as % of merchandise imports) in Ores and metals in 2002 to that in 2003?
Keep it short and to the point. 0.95. What is the ratio of the Amount of imports(as % of merchandise imports) of Manufactures in 2002 to that in 2003?
Your answer should be very brief. 0.89. What is the ratio of the Amount of imports(as % of merchandise imports) of Fuel in 2002 to that in 2003?
Keep it short and to the point. 2.29. What is the ratio of the Amount of imports(as % of merchandise imports) in Ores and metals in 2002 to that in 2004?
Make the answer very short. 4.36. What is the ratio of the Amount of imports(as % of merchandise imports) in Manufactures in 2002 to that in 2004?
Keep it short and to the point. 0.98. What is the ratio of the Amount of imports(as % of merchandise imports) of Fuel in 2002 to that in 2004?
Your answer should be compact. 1.11. What is the ratio of the Amount of imports(as % of merchandise imports) of Ores and metals in 2002 to that in 2005?
Ensure brevity in your answer.  1.1. What is the ratio of the Amount of imports(as % of merchandise imports) of Manufactures in 2002 to that in 2005?
Offer a terse response. 0.9. What is the ratio of the Amount of imports(as % of merchandise imports) in Fuel in 2002 to that in 2005?
Your response must be concise. 1.11. What is the ratio of the Amount of imports(as % of merchandise imports) of Ores and metals in 2003 to that in 2004?
Your answer should be very brief. 4.58. What is the ratio of the Amount of imports(as % of merchandise imports) in Manufactures in 2003 to that in 2004?
Give a very brief answer. 1.1. What is the ratio of the Amount of imports(as % of merchandise imports) of Fuel in 2003 to that in 2004?
Keep it short and to the point. 0.48. What is the ratio of the Amount of imports(as % of merchandise imports) of Ores and metals in 2003 to that in 2005?
Give a very brief answer. 1.15. What is the ratio of the Amount of imports(as % of merchandise imports) of Manufactures in 2003 to that in 2005?
Provide a short and direct response. 1.02. What is the ratio of the Amount of imports(as % of merchandise imports) of Fuel in 2003 to that in 2005?
Make the answer very short. 0.48. What is the ratio of the Amount of imports(as % of merchandise imports) of Ores and metals in 2004 to that in 2005?
Make the answer very short. 0.25. What is the ratio of the Amount of imports(as % of merchandise imports) of Manufactures in 2004 to that in 2005?
Offer a very short reply. 0.92. What is the ratio of the Amount of imports(as % of merchandise imports) in Fuel in 2004 to that in 2005?
Your response must be concise. 1. What is the difference between the highest and the second highest Amount of imports(as % of merchandise imports) of Ores and metals?
Offer a very short reply. 0.15. What is the difference between the highest and the second highest Amount of imports(as % of merchandise imports) of Manufactures?
Offer a terse response. 0.93. What is the difference between the highest and the second highest Amount of imports(as % of merchandise imports) in Fuel?
Your answer should be very brief. 4.57. What is the difference between the highest and the lowest Amount of imports(as % of merchandise imports) of Ores and metals?
Provide a short and direct response. 2.64. What is the difference between the highest and the lowest Amount of imports(as % of merchandise imports) of Manufactures?
Ensure brevity in your answer.  23.97. What is the difference between the highest and the lowest Amount of imports(as % of merchandise imports) of Fuel?
Offer a very short reply. 19.55. 